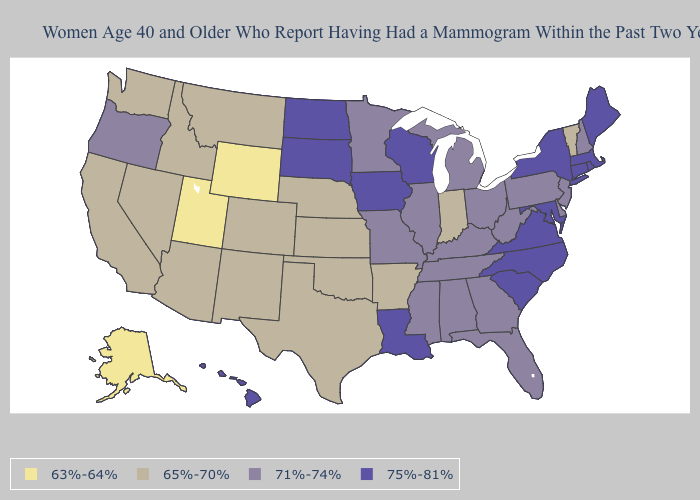What is the value of Hawaii?
Short answer required. 75%-81%. Does North Carolina have the highest value in the South?
Keep it brief. Yes. What is the value of Rhode Island?
Answer briefly. 75%-81%. Name the states that have a value in the range 75%-81%?
Short answer required. Connecticut, Hawaii, Iowa, Louisiana, Maine, Maryland, Massachusetts, New York, North Carolina, North Dakota, Rhode Island, South Carolina, South Dakota, Virginia, Wisconsin. What is the value of Florida?
Keep it brief. 71%-74%. Does Utah have the lowest value in the USA?
Short answer required. Yes. Name the states that have a value in the range 63%-64%?
Keep it brief. Alaska, Utah, Wyoming. Does the first symbol in the legend represent the smallest category?
Concise answer only. Yes. What is the lowest value in the South?
Write a very short answer. 65%-70%. Does the map have missing data?
Be succinct. No. Among the states that border Vermont , does New Hampshire have the highest value?
Concise answer only. No. Name the states that have a value in the range 65%-70%?
Write a very short answer. Arizona, Arkansas, California, Colorado, Idaho, Indiana, Kansas, Montana, Nebraska, Nevada, New Mexico, Oklahoma, Texas, Vermont, Washington. Does the first symbol in the legend represent the smallest category?
Give a very brief answer. Yes. Does Iowa have the same value as Vermont?
Be succinct. No. Name the states that have a value in the range 63%-64%?
Concise answer only. Alaska, Utah, Wyoming. 